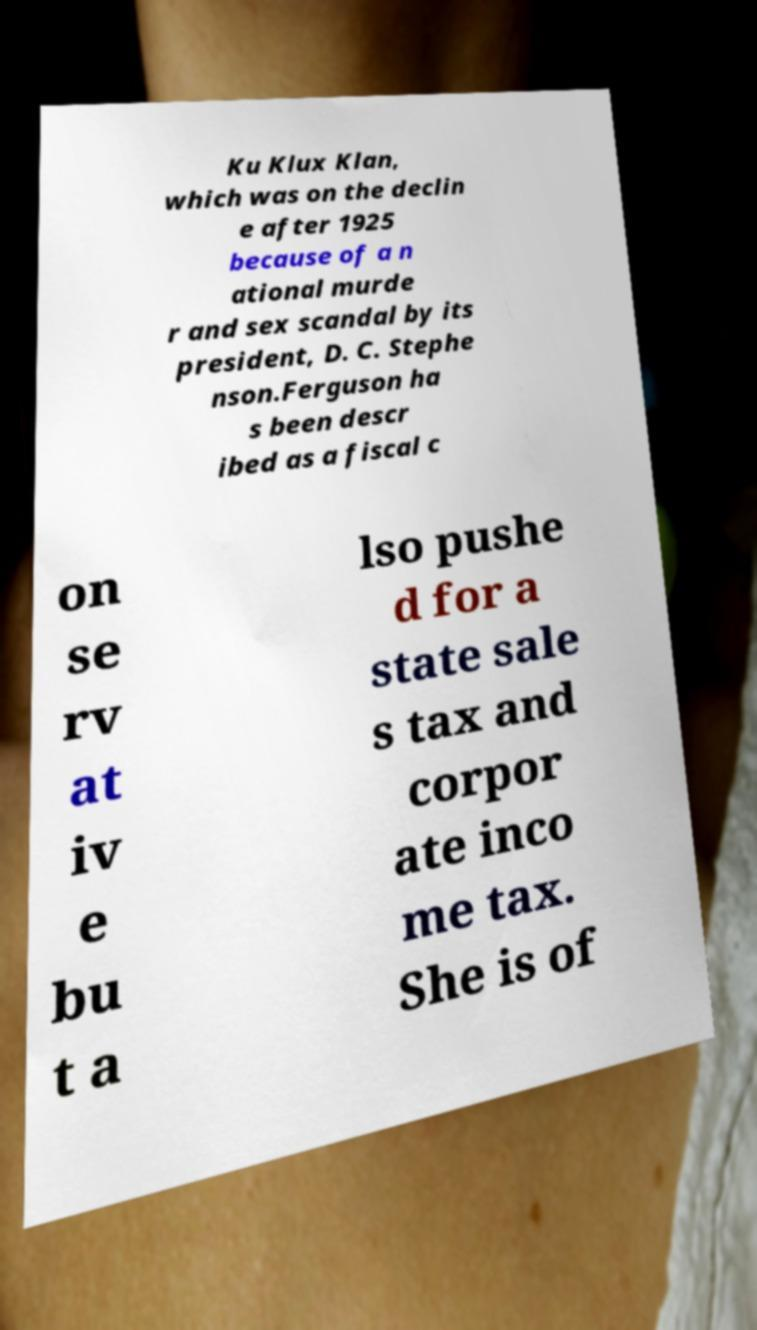Please read and relay the text visible in this image. What does it say? Ku Klux Klan, which was on the declin e after 1925 because of a n ational murde r and sex scandal by its president, D. C. Stephe nson.Ferguson ha s been descr ibed as a fiscal c on se rv at iv e bu t a lso pushe d for a state sale s tax and corpor ate inco me tax. She is of 